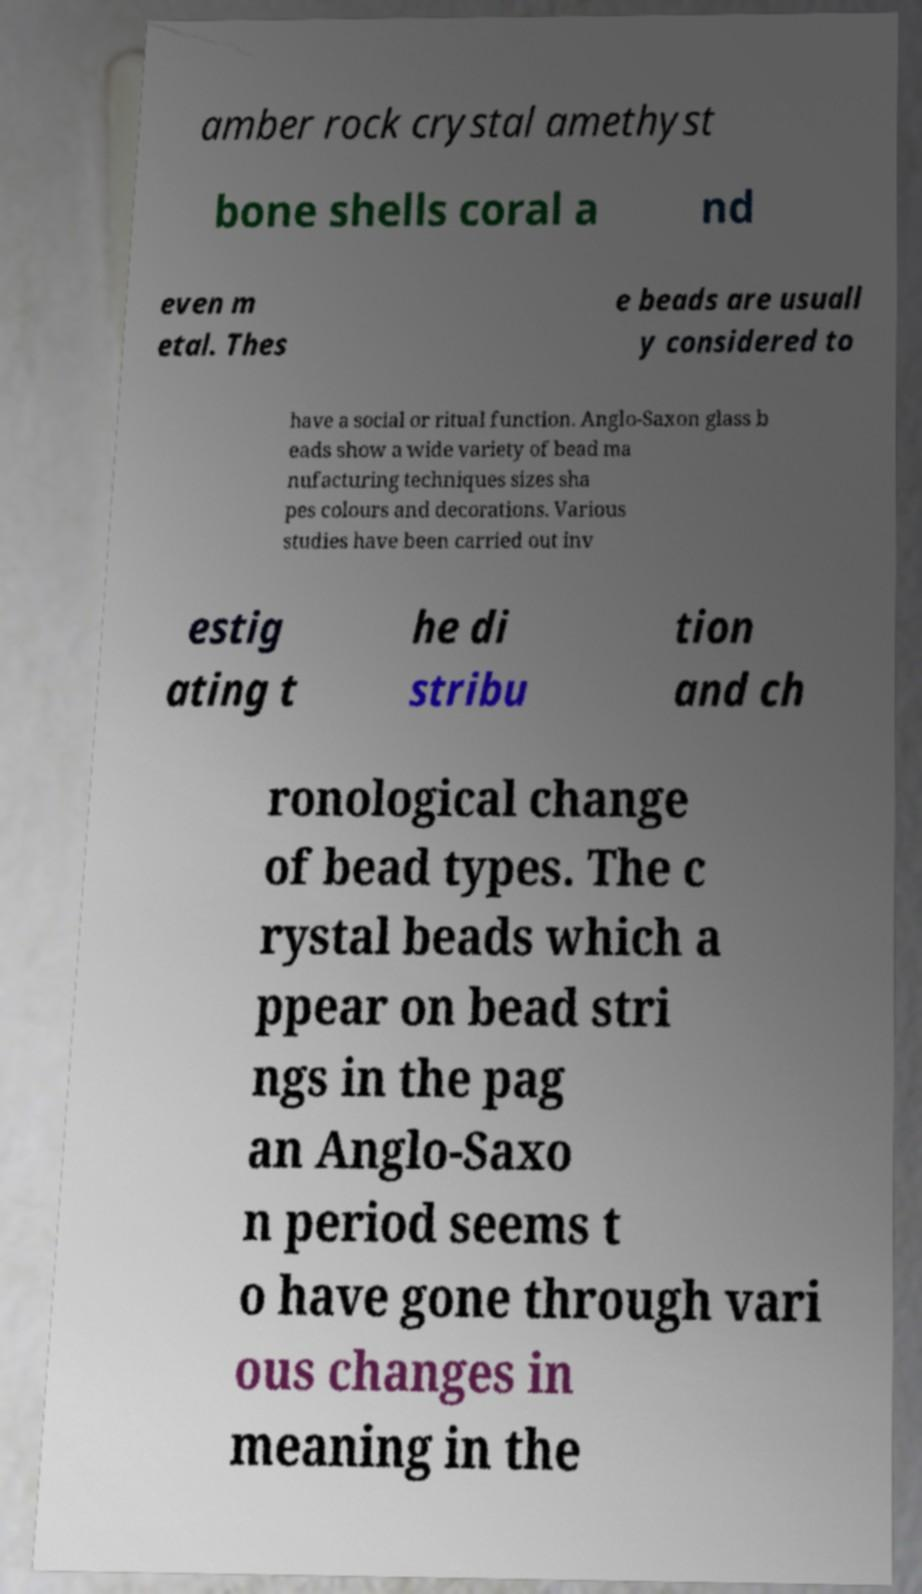Can you accurately transcribe the text from the provided image for me? amber rock crystal amethyst bone shells coral a nd even m etal. Thes e beads are usuall y considered to have a social or ritual function. Anglo-Saxon glass b eads show a wide variety of bead ma nufacturing techniques sizes sha pes colours and decorations. Various studies have been carried out inv estig ating t he di stribu tion and ch ronological change of bead types. The c rystal beads which a ppear on bead stri ngs in the pag an Anglo-Saxo n period seems t o have gone through vari ous changes in meaning in the 